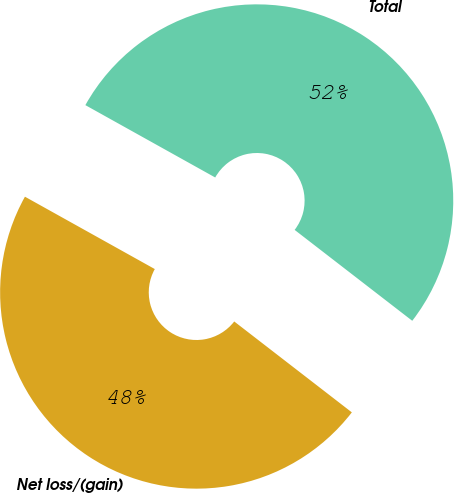<chart> <loc_0><loc_0><loc_500><loc_500><pie_chart><fcel>Net loss/(gain)<fcel>Total<nl><fcel>47.62%<fcel>52.38%<nl></chart> 